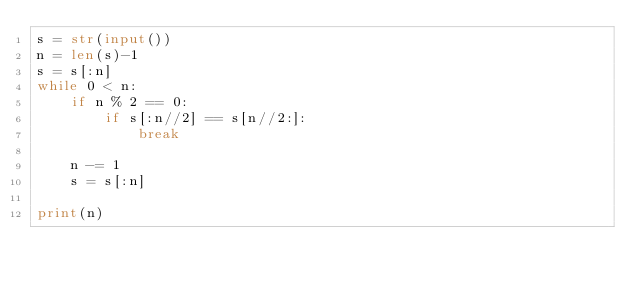<code> <loc_0><loc_0><loc_500><loc_500><_Python_>s = str(input())
n = len(s)-1
s = s[:n]
while 0 < n:
    if n % 2 == 0:
        if s[:n//2] == s[n//2:]:
            break

    n -= 1
    s = s[:n]

print(n)</code> 